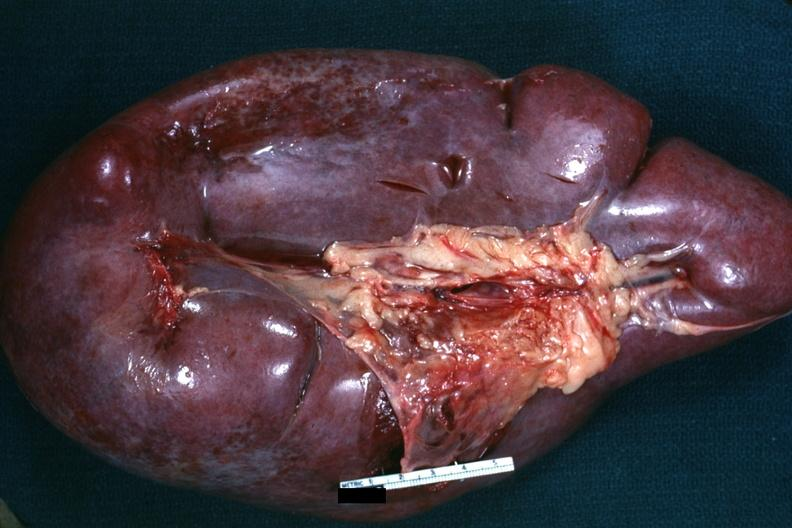s normal immature infant present?
Answer the question using a single word or phrase. No 